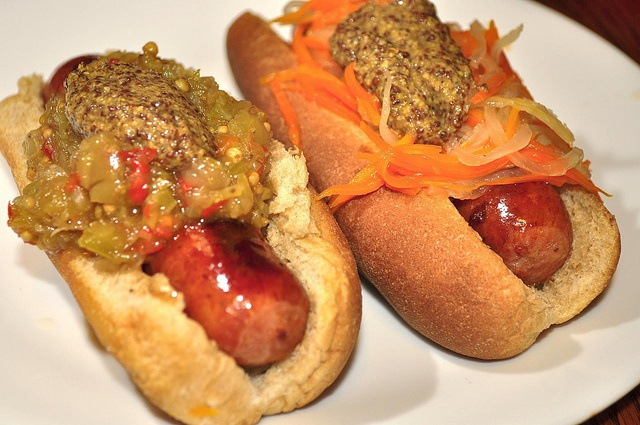Describe the objects in this image and their specific colors. I can see hot dog in lightgray, red, and orange tones, hot dog in lightgray, brown, orange, and red tones, and carrot in lightgray, red, orange, and brown tones in this image. 